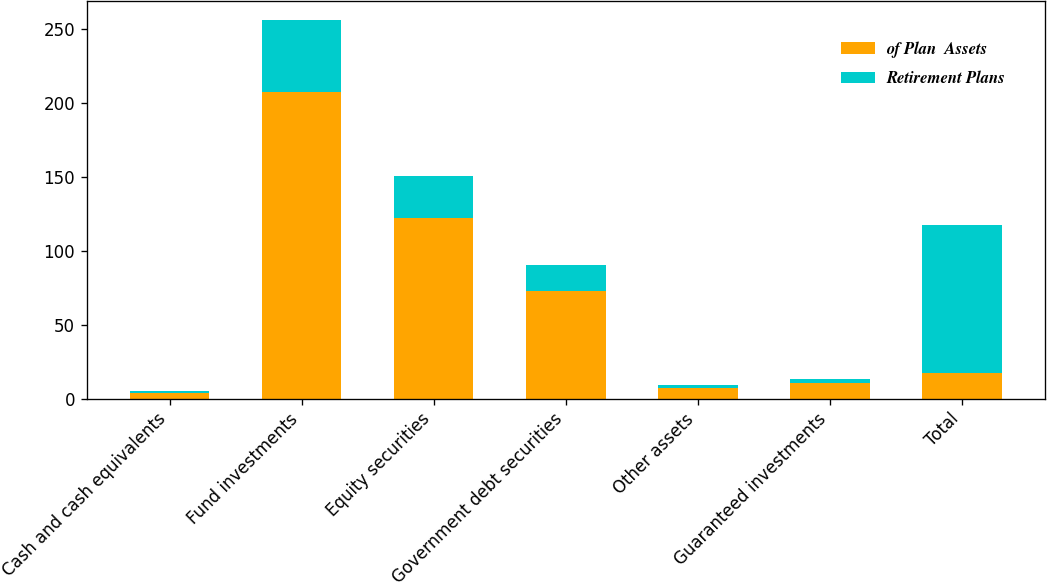Convert chart. <chart><loc_0><loc_0><loc_500><loc_500><stacked_bar_chart><ecel><fcel>Cash and cash equivalents<fcel>Fund investments<fcel>Equity securities<fcel>Government debt securities<fcel>Other assets<fcel>Guaranteed investments<fcel>Total<nl><fcel>of Plan  Assets<fcel>3.9<fcel>207.4<fcel>122.1<fcel>73<fcel>7.3<fcel>10.4<fcel>17.2<nl><fcel>Retirement Plans<fcel>0.9<fcel>48.9<fcel>28.8<fcel>17.2<fcel>1.7<fcel>2.5<fcel>100<nl></chart> 